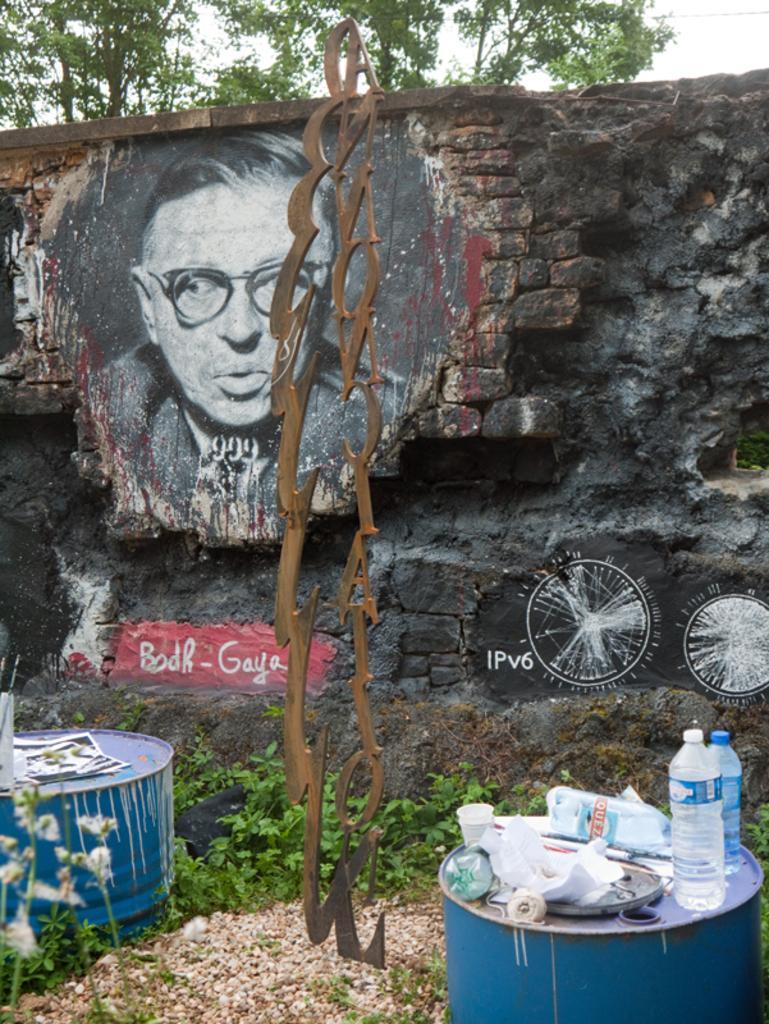In one or two sentences, can you explain what this image depicts? In this image, we can see a brick wall. There is a human painting. And here there is a 2 drums are placed. On top of the drum, we can see bottles, paper, cup. Here we can found some plants. At the background, we can see a tree and sky. The painting, the human is wearing a glasses. 